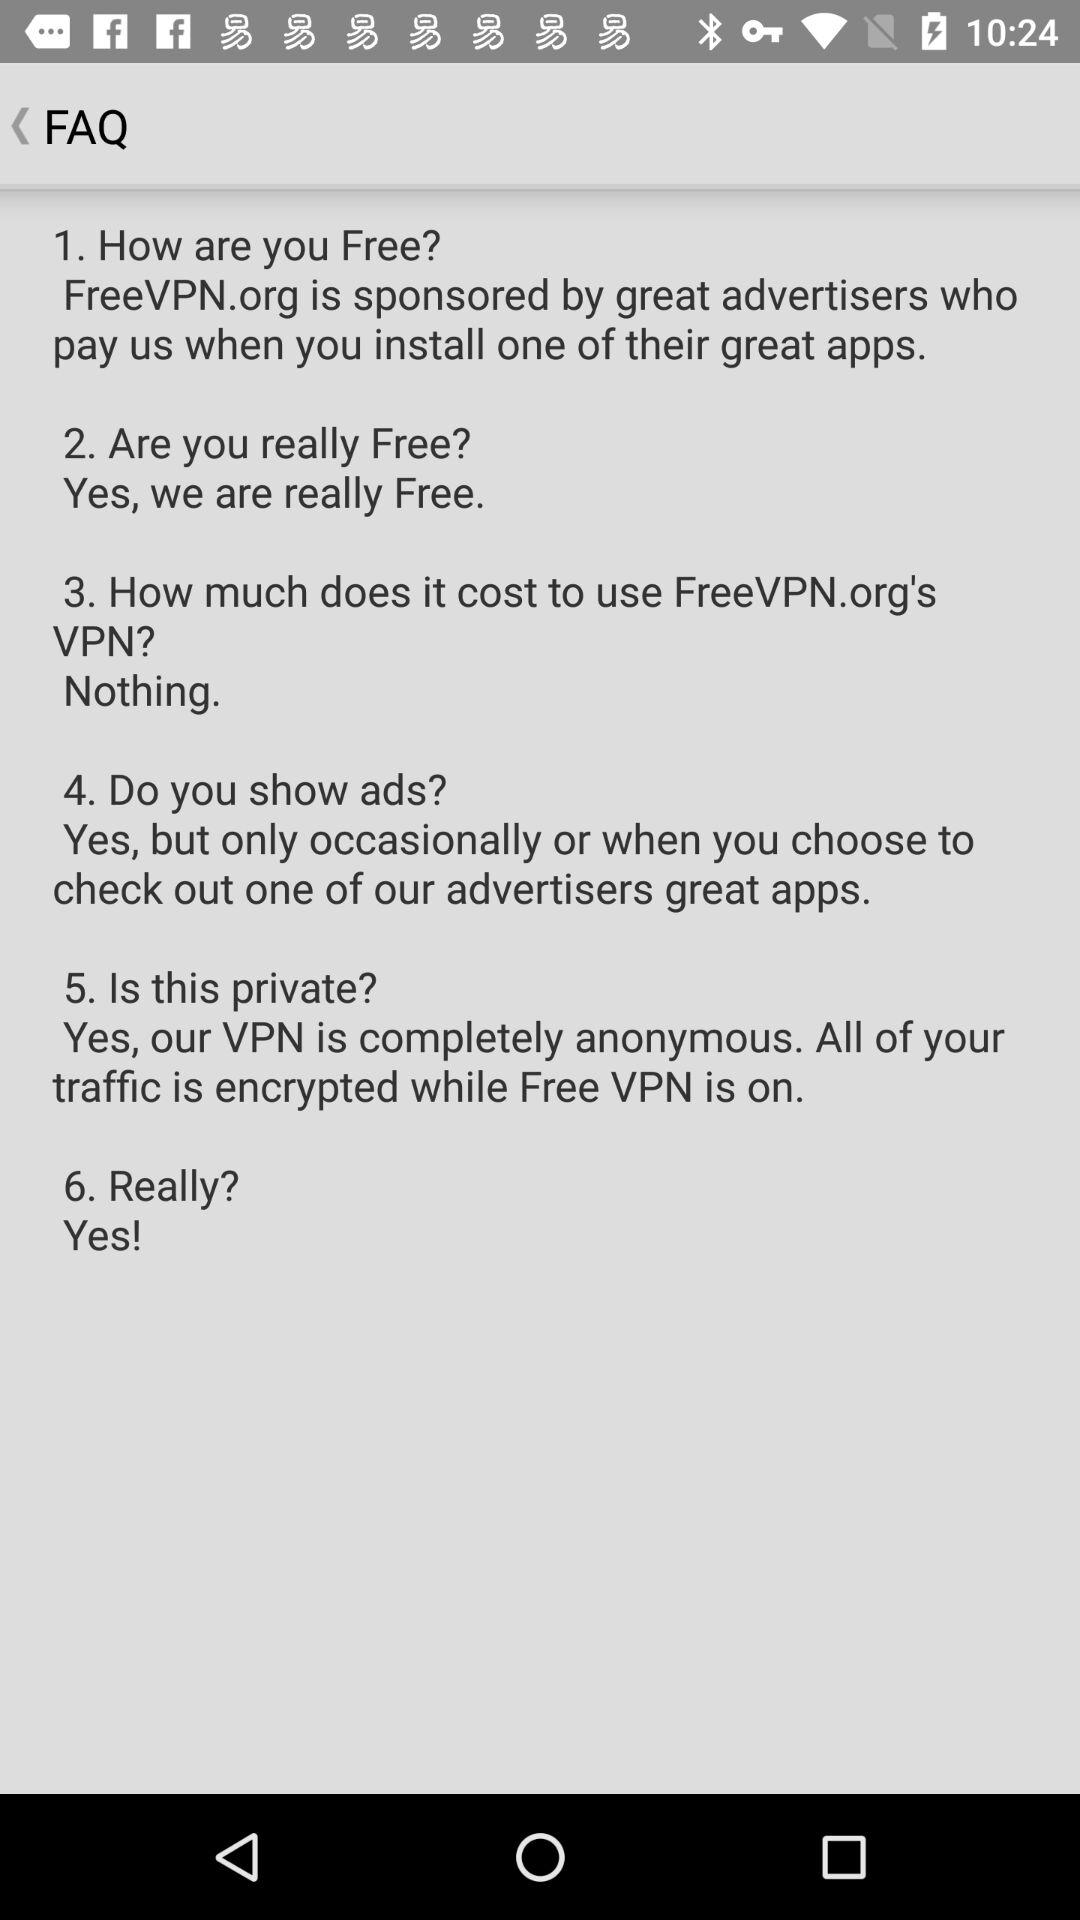How much do we have to pay to use FreeVPN.org's VPN? You have to pay nothing to use FreeVPN.org's VPN. 